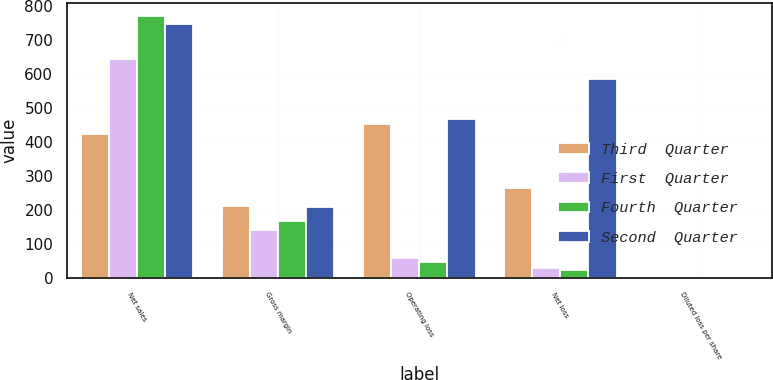Convert chart to OTSL. <chart><loc_0><loc_0><loc_500><loc_500><stacked_bar_chart><ecel><fcel>Net sales<fcel>Gross margin<fcel>Operating loss<fcel>Net loss<fcel>Diluted loss per share<nl><fcel>Third  Quarter<fcel>423.9<fcel>212.6<fcel>452<fcel>265.9<fcel>0.44<nl><fcel>First  Quarter<fcel>645.9<fcel>143<fcel>59<fcel>30.4<fcel>0.05<nl><fcel>Fourth  Quarter<fcel>771.2<fcel>168.2<fcel>46.7<fcel>24.2<fcel>0.04<nl><fcel>Second  Quarter<fcel>748<fcel>209.2<fcel>467.6<fcel>586.5<fcel>0.97<nl></chart> 